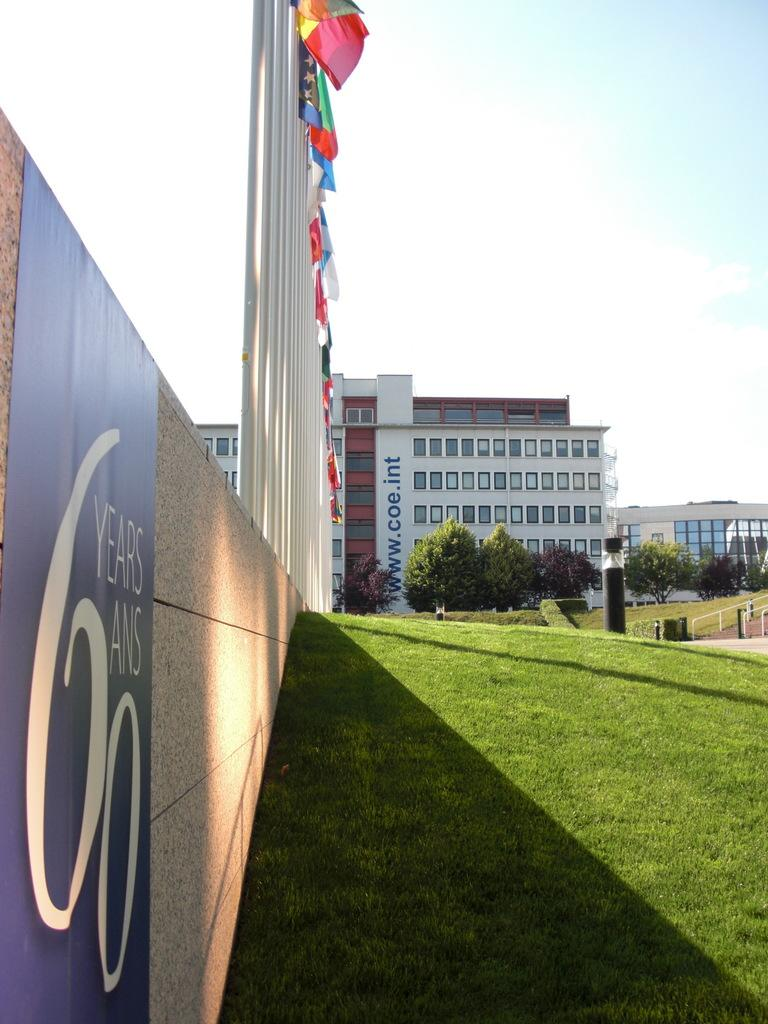<image>
Render a clear and concise summary of the photo. Outside an building with flags on poles lined up outside and a grass area with a wall and a banner reading 60 years 